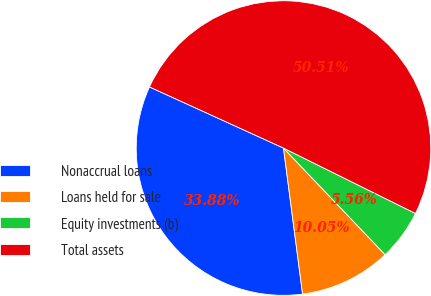Convert chart. <chart><loc_0><loc_0><loc_500><loc_500><pie_chart><fcel>Nonaccrual loans<fcel>Loans held for sale<fcel>Equity investments (b)<fcel>Total assets<nl><fcel>33.88%<fcel>10.05%<fcel>5.56%<fcel>50.51%<nl></chart> 